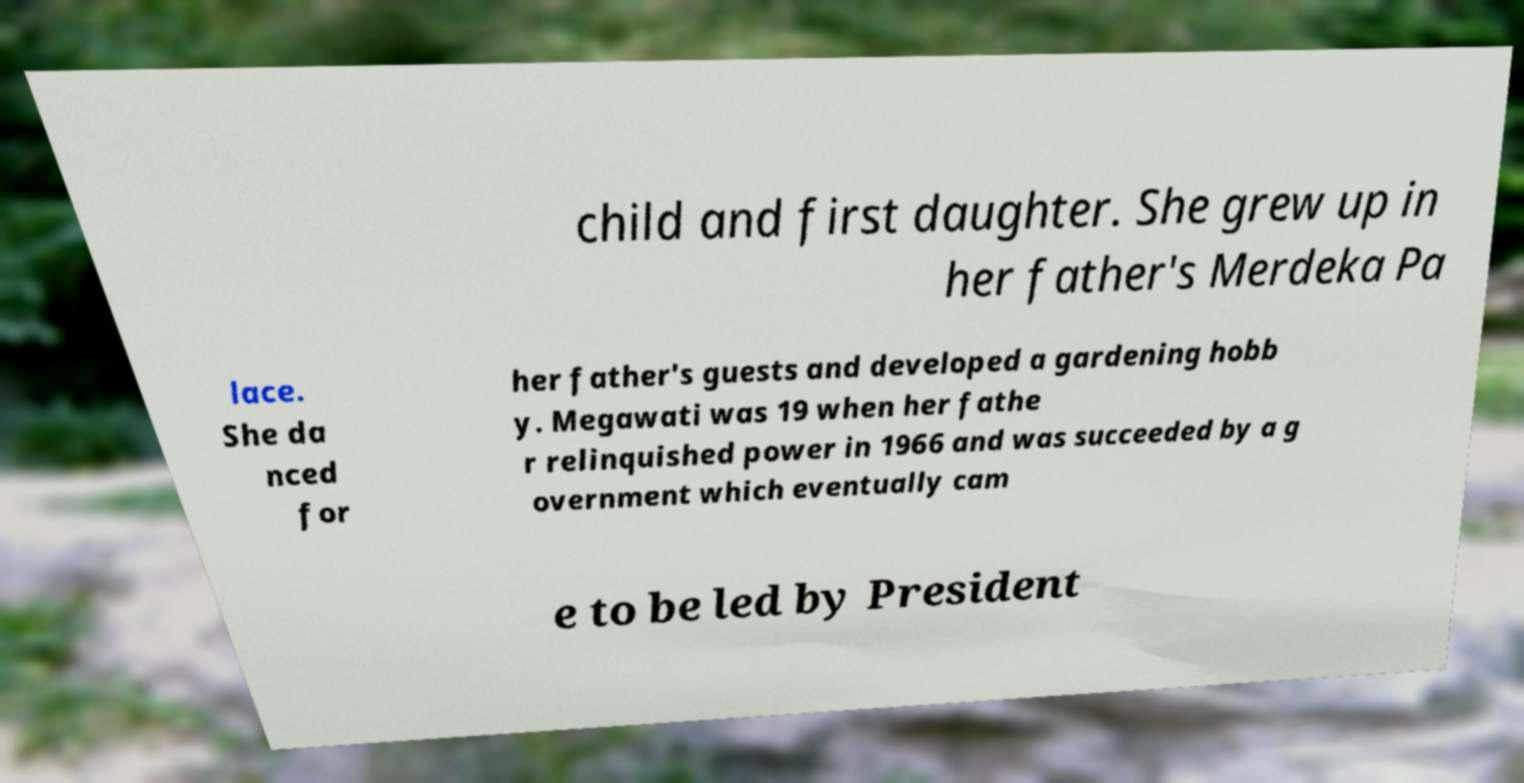For documentation purposes, I need the text within this image transcribed. Could you provide that? child and first daughter. She grew up in her father's Merdeka Pa lace. She da nced for her father's guests and developed a gardening hobb y. Megawati was 19 when her fathe r relinquished power in 1966 and was succeeded by a g overnment which eventually cam e to be led by President 